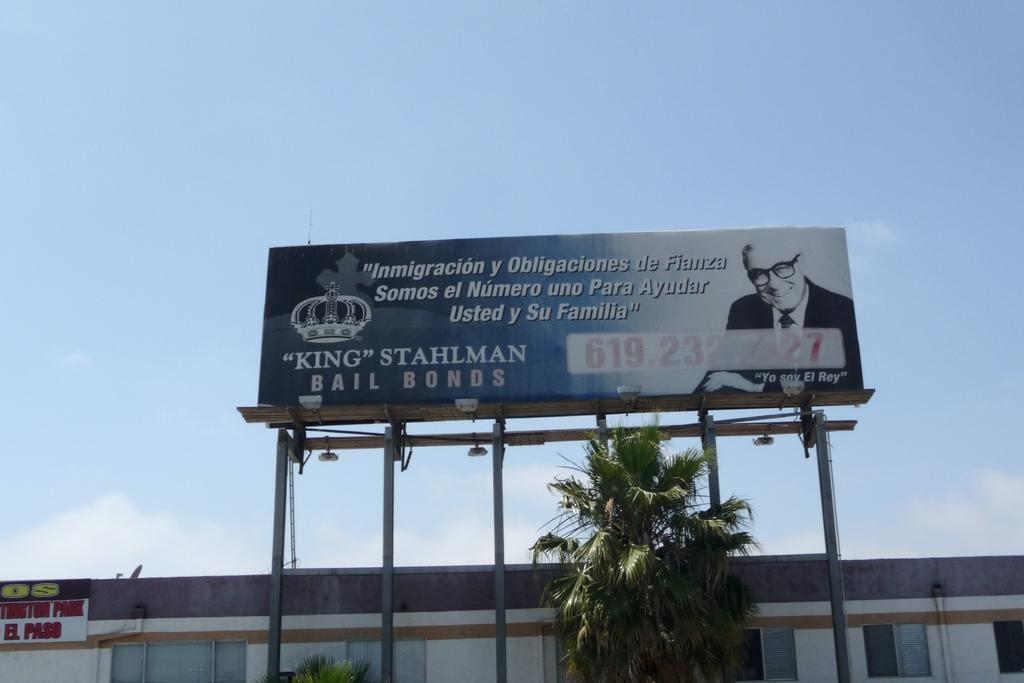Provide a one-sentence caption for the provided image. A large bill board with the word king stahlam written on it. 